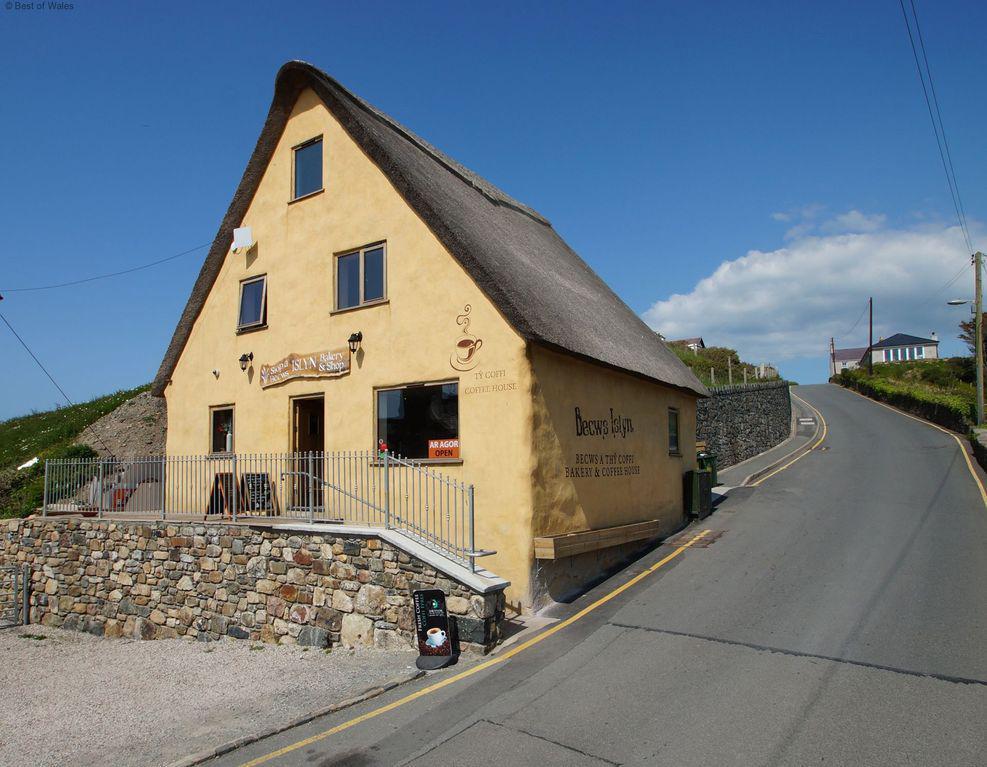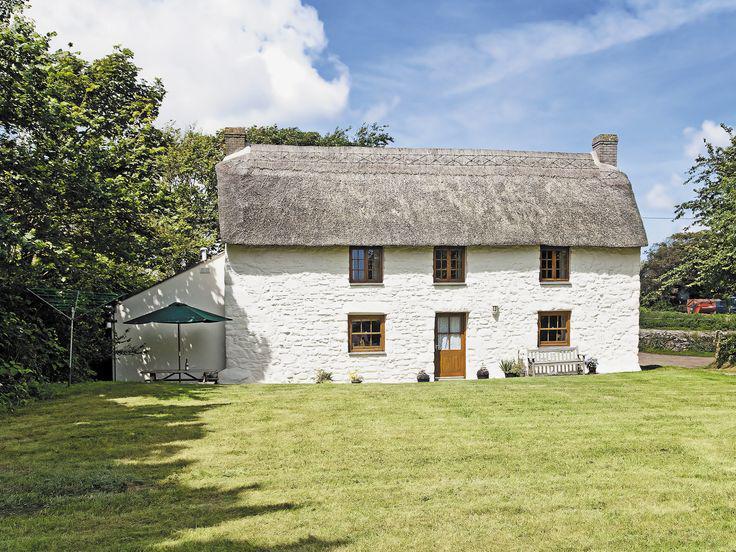The first image is the image on the left, the second image is the image on the right. Assess this claim about the two images: "In each image, a building has a gray roof that curves around items like windows or doors instead of just overhanging them.". Correct or not? Answer yes or no. No. 